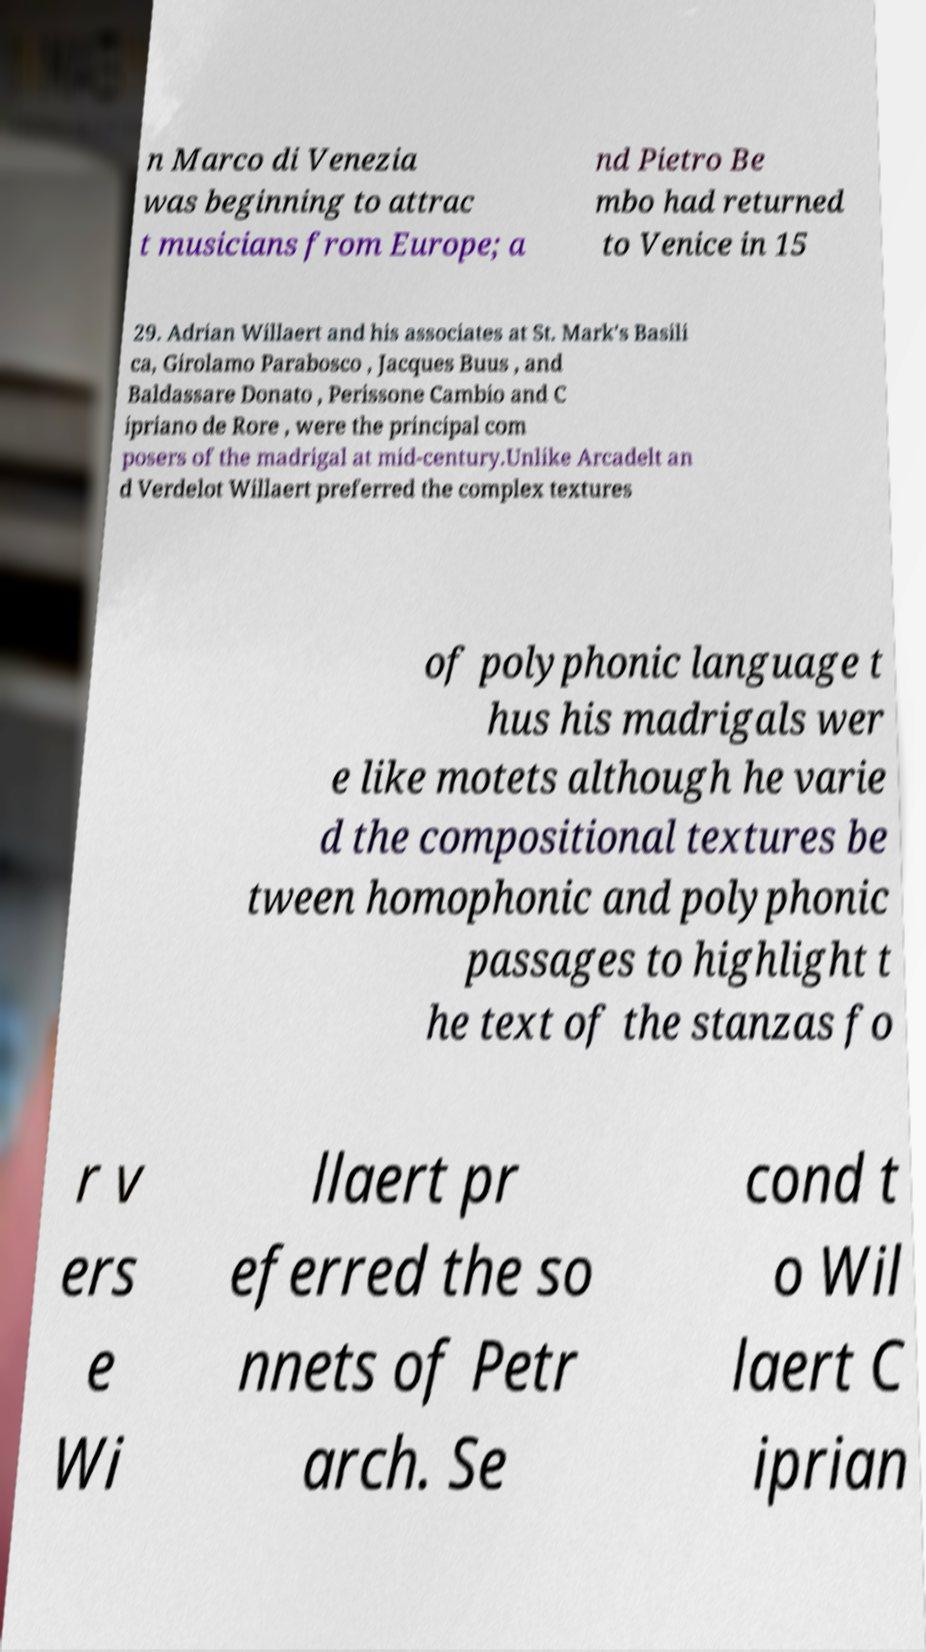There's text embedded in this image that I need extracted. Can you transcribe it verbatim? n Marco di Venezia was beginning to attrac t musicians from Europe; a nd Pietro Be mbo had returned to Venice in 15 29. Adrian Willaert and his associates at St. Mark's Basili ca, Girolamo Parabosco , Jacques Buus , and Baldassare Donato , Perissone Cambio and C ipriano de Rore , were the principal com posers of the madrigal at mid-century.Unlike Arcadelt an d Verdelot Willaert preferred the complex textures of polyphonic language t hus his madrigals wer e like motets although he varie d the compositional textures be tween homophonic and polyphonic passages to highlight t he text of the stanzas fo r v ers e Wi llaert pr eferred the so nnets of Petr arch. Se cond t o Wil laert C iprian 